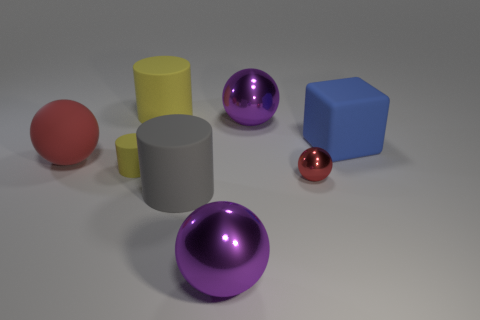How many objects are either balls or large objects that are behind the tiny yellow object?
Give a very brief answer. 6. What is the size of the object on the right side of the red thing that is on the right side of the big purple thing behind the gray rubber cylinder?
Ensure brevity in your answer.  Large. There is a gray thing that is the same size as the blue object; what material is it?
Keep it short and to the point. Rubber. Is there a cyan ball that has the same size as the gray cylinder?
Give a very brief answer. No. Is the size of the purple metal object that is in front of the gray rubber thing the same as the tiny shiny object?
Your answer should be compact. No. What is the shape of the big object that is on the right side of the big gray object and behind the big blue matte block?
Provide a succinct answer. Sphere. Are there more balls that are on the right side of the large yellow matte cylinder than large red things?
Your response must be concise. Yes. What size is the sphere that is the same material as the gray cylinder?
Offer a very short reply. Large. What number of big matte cubes have the same color as the tiny ball?
Keep it short and to the point. 0. Does the big cylinder that is in front of the big matte ball have the same color as the tiny matte cylinder?
Provide a succinct answer. No. 